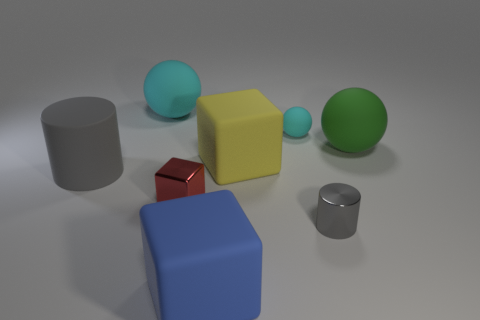Subtract all big matte blocks. How many blocks are left? 1 Subtract all green cylinders. How many cyan spheres are left? 2 Add 1 purple cylinders. How many objects exist? 9 Subtract all cylinders. How many objects are left? 6 Subtract all gray spheres. Subtract all red blocks. How many spheres are left? 3 Add 7 large yellow blocks. How many large yellow blocks are left? 8 Add 7 yellow blocks. How many yellow blocks exist? 8 Subtract 0 gray spheres. How many objects are left? 8 Subtract all tiny objects. Subtract all big yellow rubber things. How many objects are left? 4 